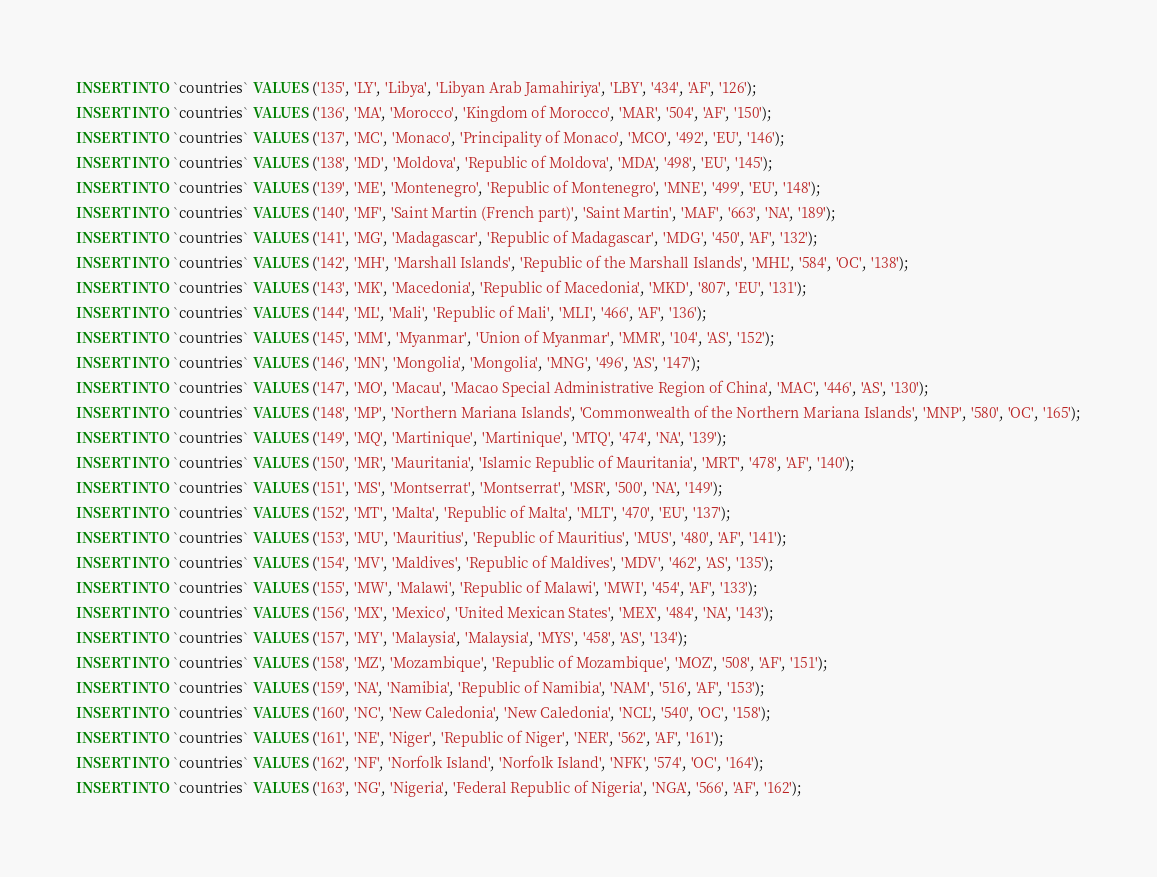<code> <loc_0><loc_0><loc_500><loc_500><_SQL_>INSERT INTO `countries` VALUES ('135', 'LY', 'Libya', 'Libyan Arab Jamahiriya', 'LBY', '434', 'AF', '126');
INSERT INTO `countries` VALUES ('136', 'MA', 'Morocco', 'Kingdom of Morocco', 'MAR', '504', 'AF', '150');
INSERT INTO `countries` VALUES ('137', 'MC', 'Monaco', 'Principality of Monaco', 'MCO', '492', 'EU', '146');
INSERT INTO `countries` VALUES ('138', 'MD', 'Moldova', 'Republic of Moldova', 'MDA', '498', 'EU', '145');
INSERT INTO `countries` VALUES ('139', 'ME', 'Montenegro', 'Republic of Montenegro', 'MNE', '499', 'EU', '148');
INSERT INTO `countries` VALUES ('140', 'MF', 'Saint Martin (French part)', 'Saint Martin', 'MAF', '663', 'NA', '189');
INSERT INTO `countries` VALUES ('141', 'MG', 'Madagascar', 'Republic of Madagascar', 'MDG', '450', 'AF', '132');
INSERT INTO `countries` VALUES ('142', 'MH', 'Marshall Islands', 'Republic of the Marshall Islands', 'MHL', '584', 'OC', '138');
INSERT INTO `countries` VALUES ('143', 'MK', 'Macedonia', 'Republic of Macedonia', 'MKD', '807', 'EU', '131');
INSERT INTO `countries` VALUES ('144', 'ML', 'Mali', 'Republic of Mali', 'MLI', '466', 'AF', '136');
INSERT INTO `countries` VALUES ('145', 'MM', 'Myanmar', 'Union of Myanmar', 'MMR', '104', 'AS', '152');
INSERT INTO `countries` VALUES ('146', 'MN', 'Mongolia', 'Mongolia', 'MNG', '496', 'AS', '147');
INSERT INTO `countries` VALUES ('147', 'MO', 'Macau', 'Macao Special Administrative Region of China', 'MAC', '446', 'AS', '130');
INSERT INTO `countries` VALUES ('148', 'MP', 'Northern Mariana Islands', 'Commonwealth of the Northern Mariana Islands', 'MNP', '580', 'OC', '165');
INSERT INTO `countries` VALUES ('149', 'MQ', 'Martinique', 'Martinique', 'MTQ', '474', 'NA', '139');
INSERT INTO `countries` VALUES ('150', 'MR', 'Mauritania', 'Islamic Republic of Mauritania', 'MRT', '478', 'AF', '140');
INSERT INTO `countries` VALUES ('151', 'MS', 'Montserrat', 'Montserrat', 'MSR', '500', 'NA', '149');
INSERT INTO `countries` VALUES ('152', 'MT', 'Malta', 'Republic of Malta', 'MLT', '470', 'EU', '137');
INSERT INTO `countries` VALUES ('153', 'MU', 'Mauritius', 'Republic of Mauritius', 'MUS', '480', 'AF', '141');
INSERT INTO `countries` VALUES ('154', 'MV', 'Maldives', 'Republic of Maldives', 'MDV', '462', 'AS', '135');
INSERT INTO `countries` VALUES ('155', 'MW', 'Malawi', 'Republic of Malawi', 'MWI', '454', 'AF', '133');
INSERT INTO `countries` VALUES ('156', 'MX', 'Mexico', 'United Mexican States', 'MEX', '484', 'NA', '143');
INSERT INTO `countries` VALUES ('157', 'MY', 'Malaysia', 'Malaysia', 'MYS', '458', 'AS', '134');
INSERT INTO `countries` VALUES ('158', 'MZ', 'Mozambique', 'Republic of Mozambique', 'MOZ', '508', 'AF', '151');
INSERT INTO `countries` VALUES ('159', 'NA', 'Namibia', 'Republic of Namibia', 'NAM', '516', 'AF', '153');
INSERT INTO `countries` VALUES ('160', 'NC', 'New Caledonia', 'New Caledonia', 'NCL', '540', 'OC', '158');
INSERT INTO `countries` VALUES ('161', 'NE', 'Niger', 'Republic of Niger', 'NER', '562', 'AF', '161');
INSERT INTO `countries` VALUES ('162', 'NF', 'Norfolk Island', 'Norfolk Island', 'NFK', '574', 'OC', '164');
INSERT INTO `countries` VALUES ('163', 'NG', 'Nigeria', 'Federal Republic of Nigeria', 'NGA', '566', 'AF', '162');</code> 